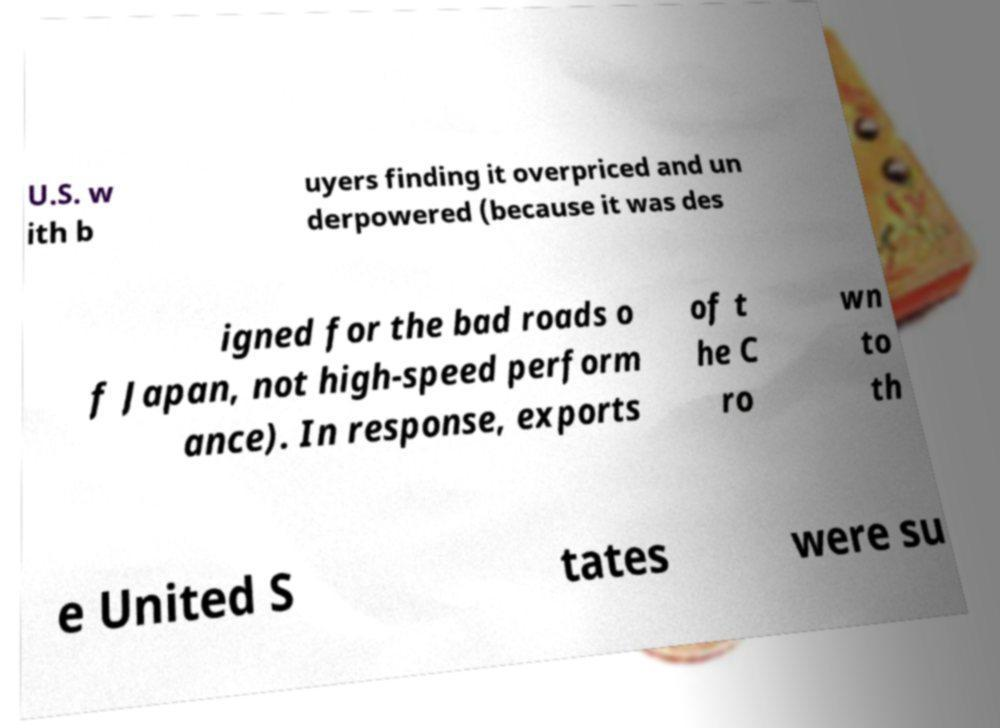Can you read and provide the text displayed in the image?This photo seems to have some interesting text. Can you extract and type it out for me? U.S. w ith b uyers finding it overpriced and un derpowered (because it was des igned for the bad roads o f Japan, not high-speed perform ance). In response, exports of t he C ro wn to th e United S tates were su 